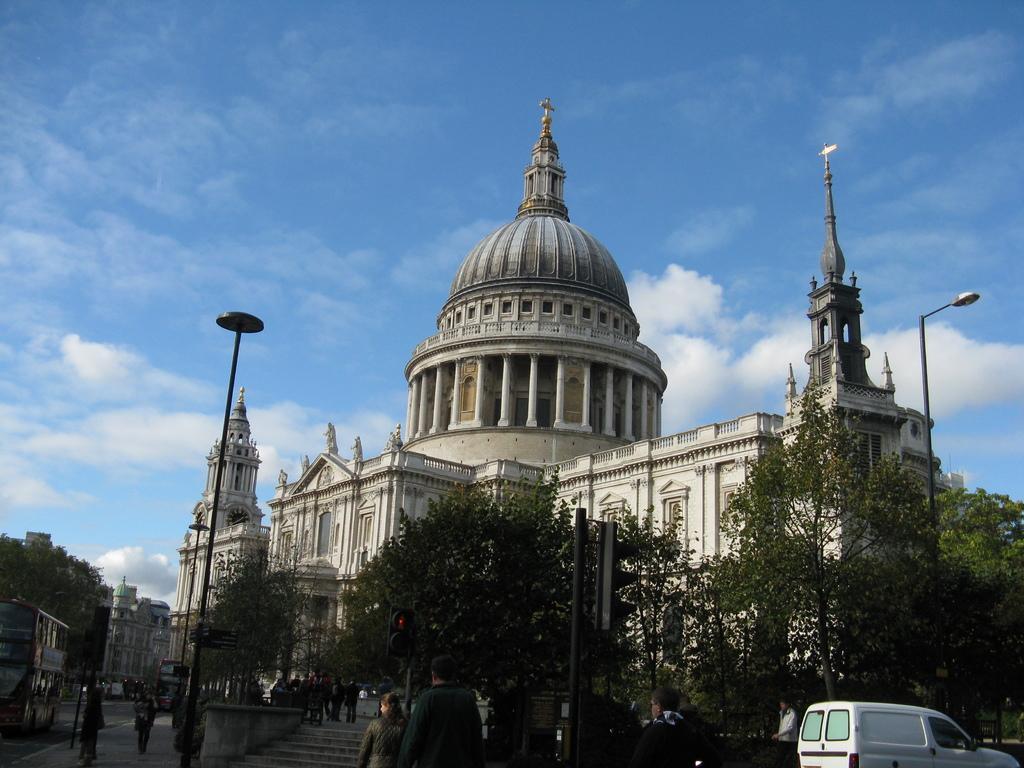How would you summarize this image in a sentence or two? In this image I can see building , in front the building I can see poles and traffic signal light , trees ,poles and vehicle at the top I can see the sky and I can see a vehicle visible on the road on the left side and I can see the building and trees on the left side. 